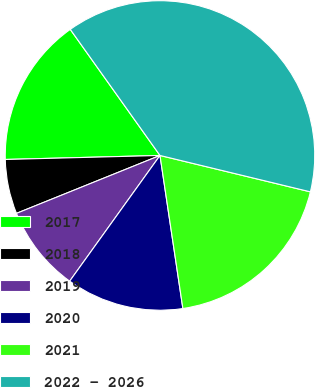<chart> <loc_0><loc_0><loc_500><loc_500><pie_chart><fcel>2017<fcel>2018<fcel>2019<fcel>2020<fcel>2021<fcel>2022 - 2026<nl><fcel>15.57%<fcel>5.69%<fcel>8.98%<fcel>12.28%<fcel>18.86%<fcel>38.62%<nl></chart> 